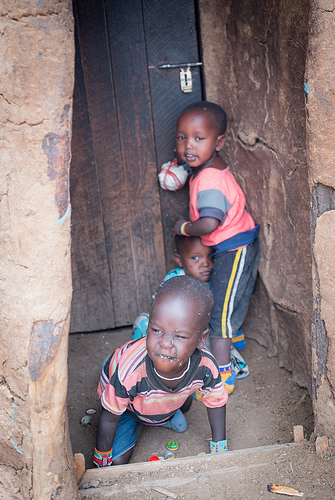<image>
Can you confirm if the door is on the child? No. The door is not positioned on the child. They may be near each other, but the door is not supported by or resting on top of the child. Is the ball in front of the child? No. The ball is not in front of the child. The spatial positioning shows a different relationship between these objects. 